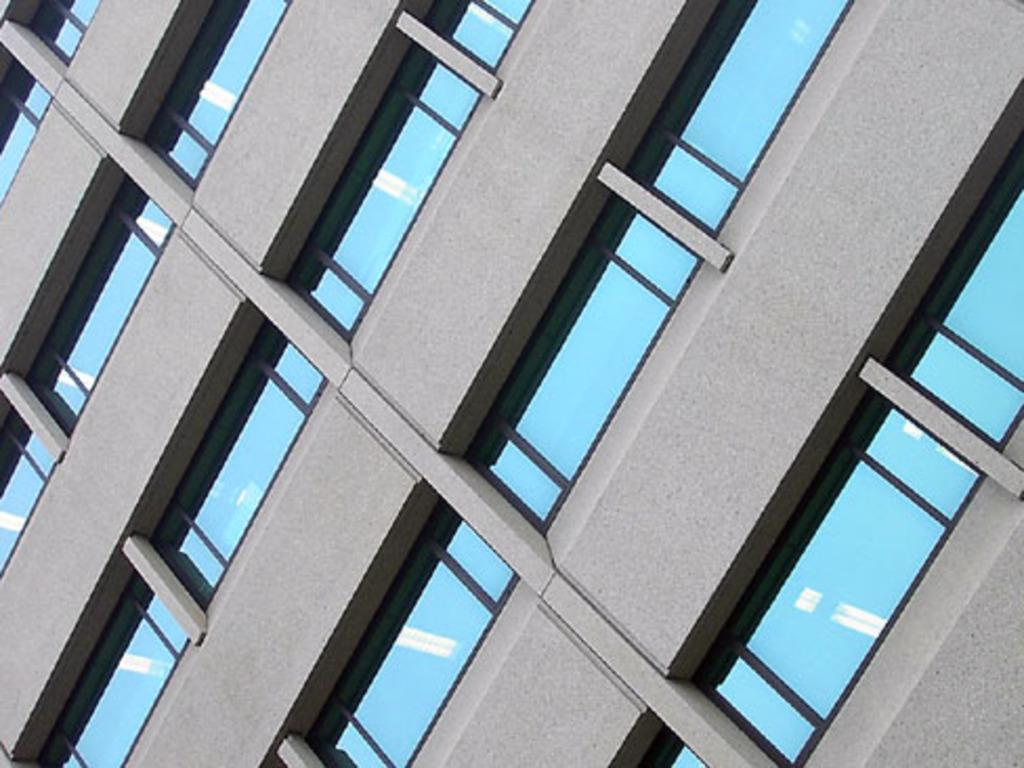What type of structure is present in the image? There is a building in the image. What feature can be observed on the building? The building consists of windows. How many copies of the building can be seen in the image? There is only one building present in the image, so it cannot be copied within the image. 